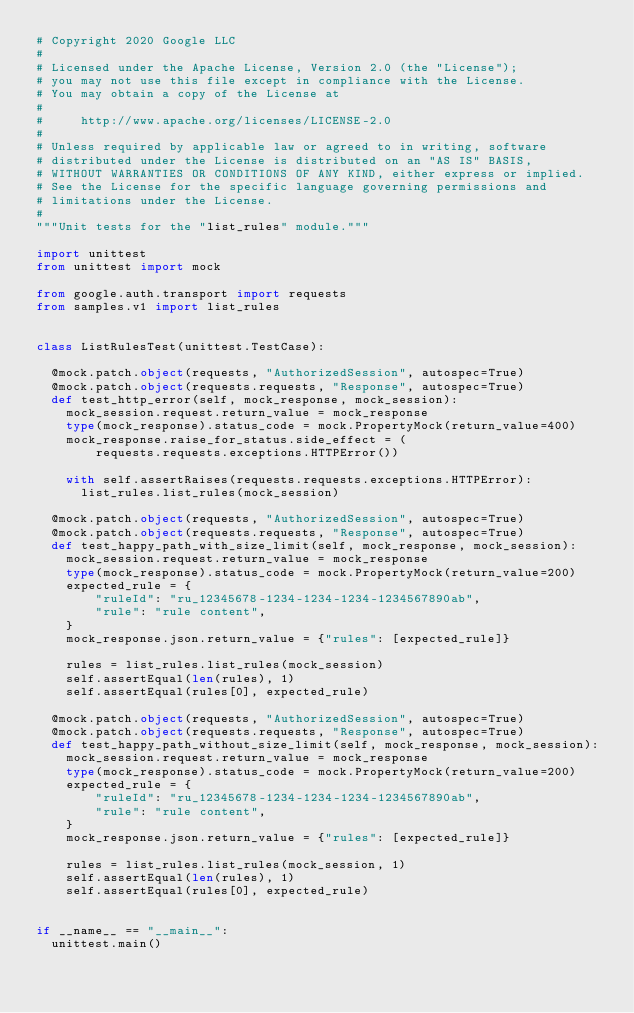Convert code to text. <code><loc_0><loc_0><loc_500><loc_500><_Python_># Copyright 2020 Google LLC
#
# Licensed under the Apache License, Version 2.0 (the "License");
# you may not use this file except in compliance with the License.
# You may obtain a copy of the License at
#
#     http://www.apache.org/licenses/LICENSE-2.0
#
# Unless required by applicable law or agreed to in writing, software
# distributed under the License is distributed on an "AS IS" BASIS,
# WITHOUT WARRANTIES OR CONDITIONS OF ANY KIND, either express or implied.
# See the License for the specific language governing permissions and
# limitations under the License.
#
"""Unit tests for the "list_rules" module."""

import unittest
from unittest import mock

from google.auth.transport import requests
from samples.v1 import list_rules


class ListRulesTest(unittest.TestCase):

  @mock.patch.object(requests, "AuthorizedSession", autospec=True)
  @mock.patch.object(requests.requests, "Response", autospec=True)
  def test_http_error(self, mock_response, mock_session):
    mock_session.request.return_value = mock_response
    type(mock_response).status_code = mock.PropertyMock(return_value=400)
    mock_response.raise_for_status.side_effect = (
        requests.requests.exceptions.HTTPError())

    with self.assertRaises(requests.requests.exceptions.HTTPError):
      list_rules.list_rules(mock_session)

  @mock.patch.object(requests, "AuthorizedSession", autospec=True)
  @mock.patch.object(requests.requests, "Response", autospec=True)
  def test_happy_path_with_size_limit(self, mock_response, mock_session):
    mock_session.request.return_value = mock_response
    type(mock_response).status_code = mock.PropertyMock(return_value=200)
    expected_rule = {
        "ruleId": "ru_12345678-1234-1234-1234-1234567890ab",
        "rule": "rule content",
    }
    mock_response.json.return_value = {"rules": [expected_rule]}

    rules = list_rules.list_rules(mock_session)
    self.assertEqual(len(rules), 1)
    self.assertEqual(rules[0], expected_rule)

  @mock.patch.object(requests, "AuthorizedSession", autospec=True)
  @mock.patch.object(requests.requests, "Response", autospec=True)
  def test_happy_path_without_size_limit(self, mock_response, mock_session):
    mock_session.request.return_value = mock_response
    type(mock_response).status_code = mock.PropertyMock(return_value=200)
    expected_rule = {
        "ruleId": "ru_12345678-1234-1234-1234-1234567890ab",
        "rule": "rule content",
    }
    mock_response.json.return_value = {"rules": [expected_rule]}

    rules = list_rules.list_rules(mock_session, 1)
    self.assertEqual(len(rules), 1)
    self.assertEqual(rules[0], expected_rule)


if __name__ == "__main__":
  unittest.main()
</code> 